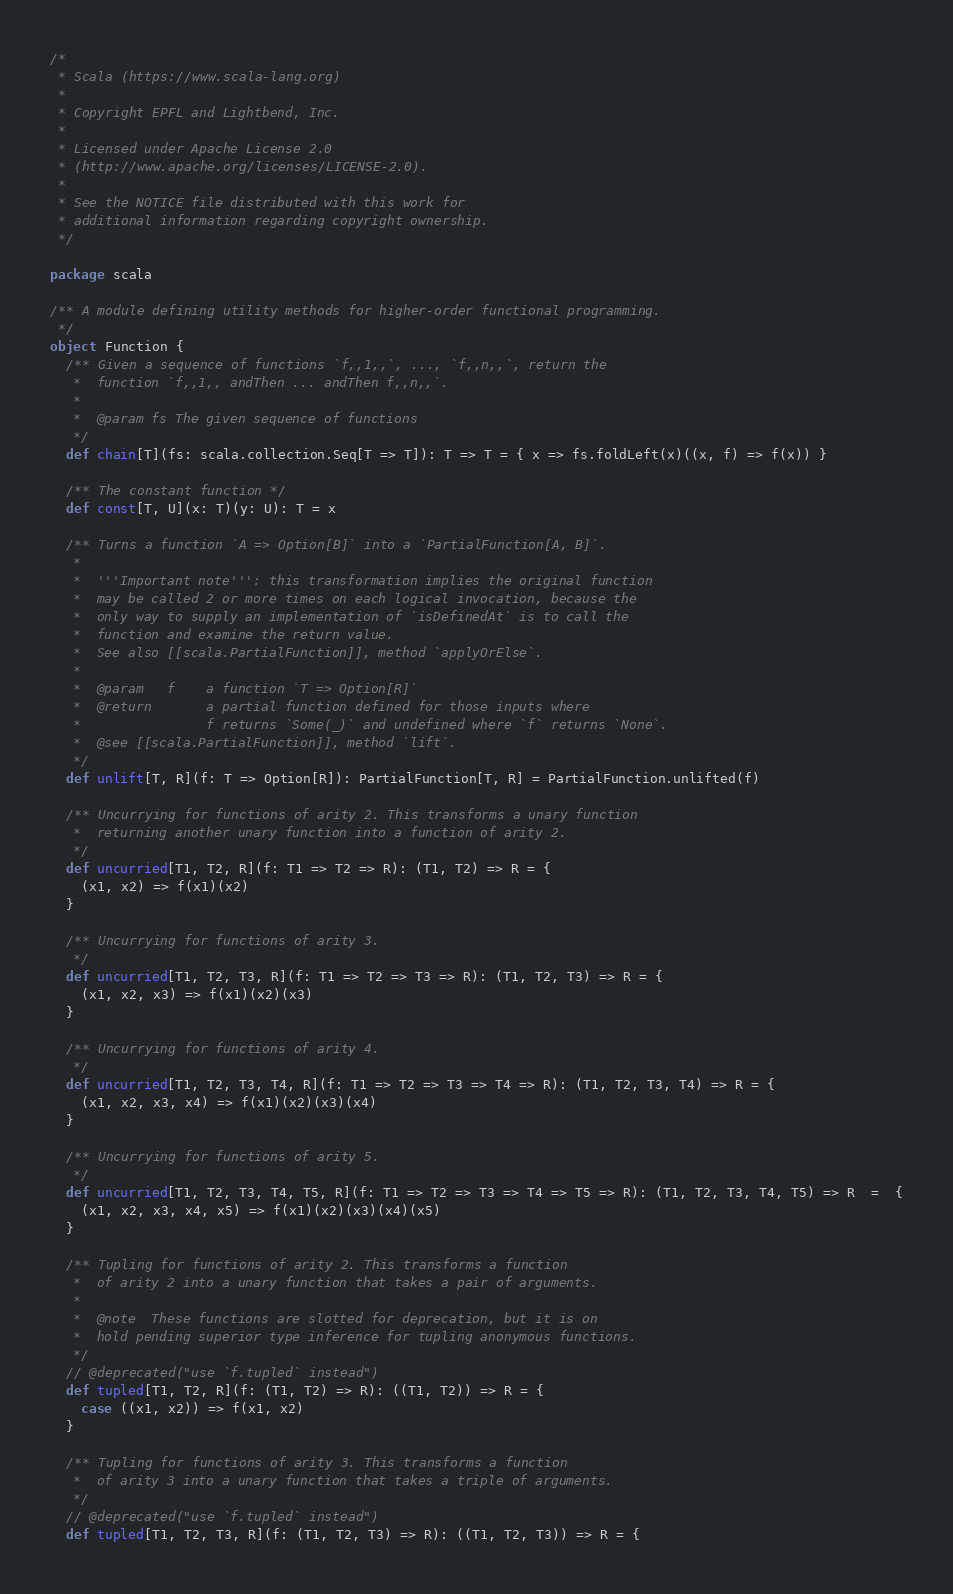<code> <loc_0><loc_0><loc_500><loc_500><_Scala_>/*
 * Scala (https://www.scala-lang.org)
 *
 * Copyright EPFL and Lightbend, Inc.
 *
 * Licensed under Apache License 2.0
 * (http://www.apache.org/licenses/LICENSE-2.0).
 *
 * See the NOTICE file distributed with this work for
 * additional information regarding copyright ownership.
 */

package scala

/** A module defining utility methods for higher-order functional programming.
 */
object Function {
  /** Given a sequence of functions `f,,1,,`, ..., `f,,n,,`, return the
   *  function `f,,1,, andThen ... andThen f,,n,,`.
   *
   *  @param fs The given sequence of functions
   */
  def chain[T](fs: scala.collection.Seq[T => T]): T => T = { x => fs.foldLeft(x)((x, f) => f(x)) }

  /** The constant function */
  def const[T, U](x: T)(y: U): T = x

  /** Turns a function `A => Option[B]` into a `PartialFunction[A, B]`.
   *
   *  '''Important note''': this transformation implies the original function
   *  may be called 2 or more times on each logical invocation, because the
   *  only way to supply an implementation of `isDefinedAt` is to call the
   *  function and examine the return value.
   *  See also [[scala.PartialFunction]], method `applyOrElse`.
   *
   *  @param   f    a function `T => Option[R]`
   *  @return       a partial function defined for those inputs where
   *                f returns `Some(_)` and undefined where `f` returns `None`.
   *  @see [[scala.PartialFunction]], method `lift`.
   */
  def unlift[T, R](f: T => Option[R]): PartialFunction[T, R] = PartialFunction.unlifted(f)

  /** Uncurrying for functions of arity 2. This transforms a unary function
   *  returning another unary function into a function of arity 2.
   */
  def uncurried[T1, T2, R](f: T1 => T2 => R): (T1, T2) => R = {
    (x1, x2) => f(x1)(x2)
  }

  /** Uncurrying for functions of arity 3.
   */
  def uncurried[T1, T2, T3, R](f: T1 => T2 => T3 => R): (T1, T2, T3) => R = {
    (x1, x2, x3) => f(x1)(x2)(x3)
  }

  /** Uncurrying for functions of arity 4.
   */
  def uncurried[T1, T2, T3, T4, R](f: T1 => T2 => T3 => T4 => R): (T1, T2, T3, T4) => R = {
    (x1, x2, x3, x4) => f(x1)(x2)(x3)(x4)
  }

  /** Uncurrying for functions of arity 5.
   */
  def uncurried[T1, T2, T3, T4, T5, R](f: T1 => T2 => T3 => T4 => T5 => R): (T1, T2, T3, T4, T5) => R  =  {
    (x1, x2, x3, x4, x5) => f(x1)(x2)(x3)(x4)(x5)
  }

  /** Tupling for functions of arity 2. This transforms a function
   *  of arity 2 into a unary function that takes a pair of arguments.
   *
   *  @note  These functions are slotted for deprecation, but it is on
   *  hold pending superior type inference for tupling anonymous functions.
   */
  // @deprecated("use `f.tupled` instead")
  def tupled[T1, T2, R](f: (T1, T2) => R): ((T1, T2)) => R = {
    case ((x1, x2)) => f(x1, x2)
  }

  /** Tupling for functions of arity 3. This transforms a function
   *  of arity 3 into a unary function that takes a triple of arguments.
   */
  // @deprecated("use `f.tupled` instead")
  def tupled[T1, T2, T3, R](f: (T1, T2, T3) => R): ((T1, T2, T3)) => R = {</code> 